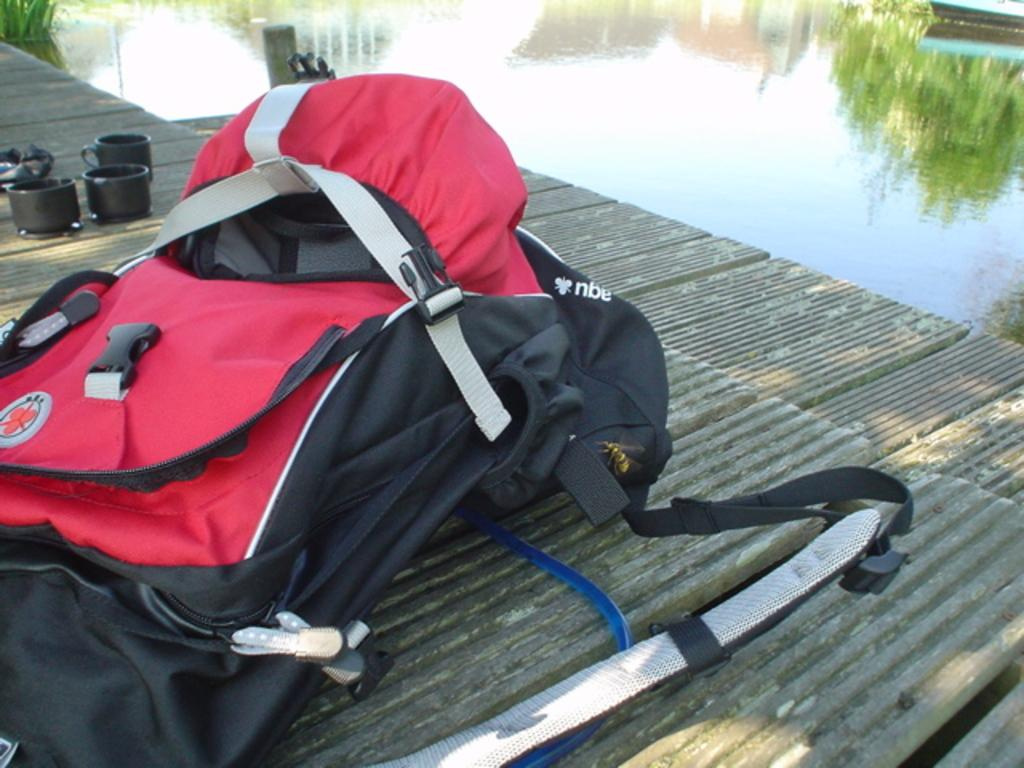What type of bag is visible in the image? There is a travel bag in the image. How many cups can be seen in the image? There are 3 cups in the image. What is the liquid visible in the image? There is water visible in the image. What reason does the visitor give for running in the image? There is no visitor present in the image, and therefore no reason for running can be determined. 